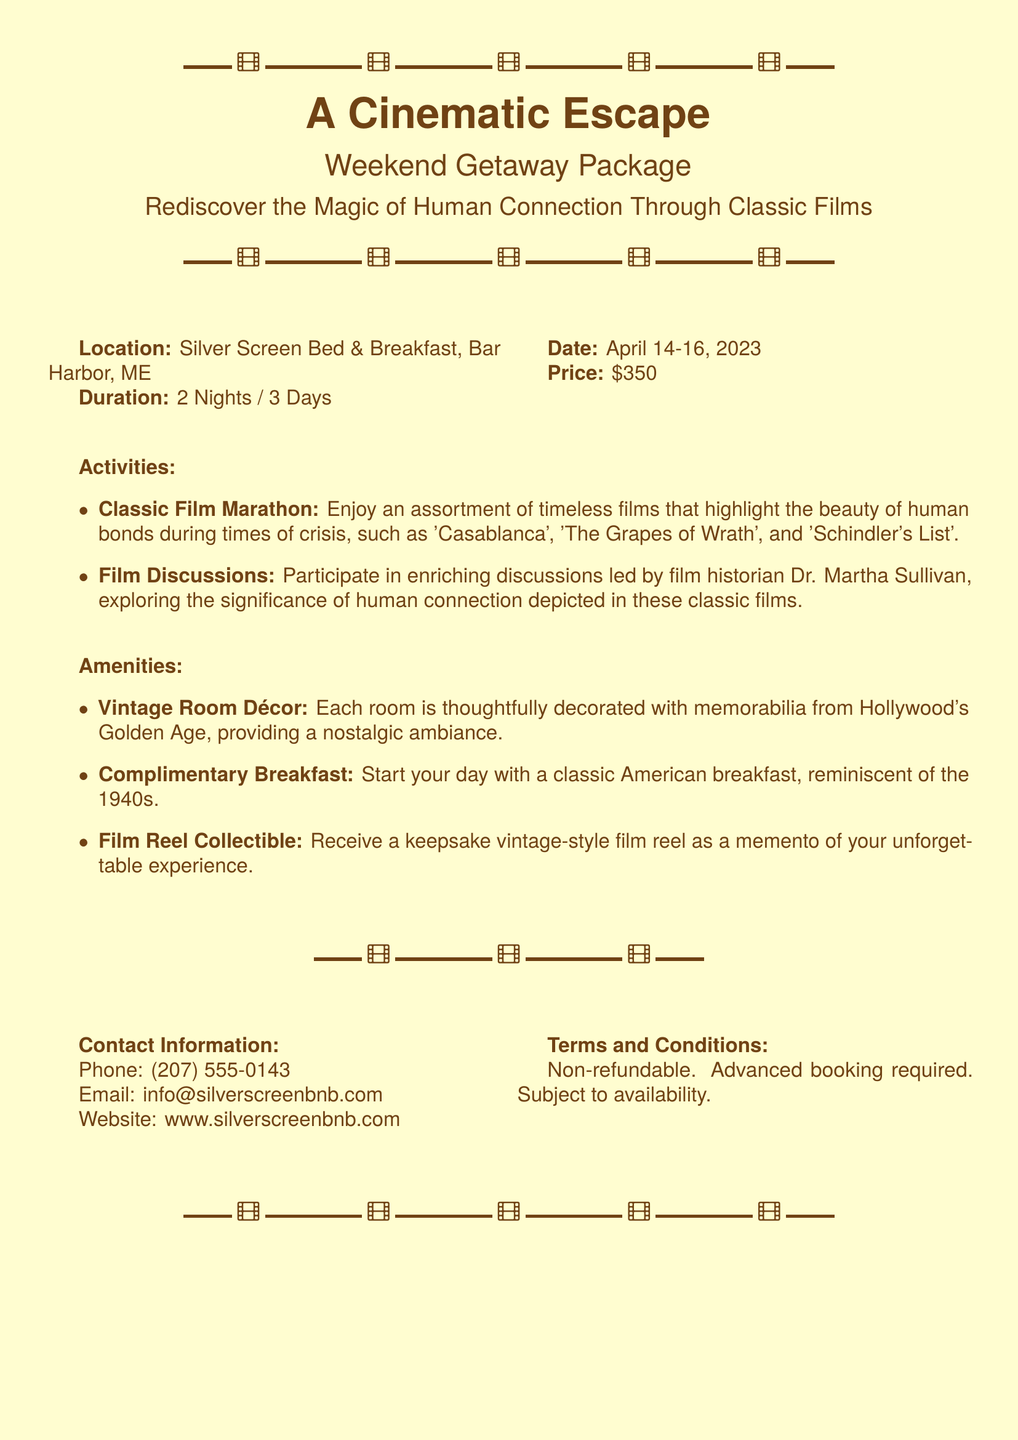What is the location of the getaway? The location is specified in the document as the Silver Screen Bed & Breakfast in Bar Harbor, ME.
Answer: Silver Screen Bed & Breakfast, Bar Harbor, ME What is the price of the weekend package? The price is clearly stated in the document under the price section.
Answer: $350 When is the getaway happening? The document provides the specific dates for the weekend getaway.
Answer: April 14-16, 2023 Who leads the film discussions? The document mentions Dr. Martha Sullivan as the film historian leading the discussions.
Answer: Dr. Martha Sullivan What type of breakfast is included? The document describes the breakfast provided as a classic American breakfast reminiscent of a certain decade.
Answer: Classic American breakfast What do guests receive as a memento? The document explains that guests will receive a specific collectible related to films.
Answer: Vintage-style film reel How many nights does the getaway last? The duration of the getaway is mentioned in the document as a specific number of nights.
Answer: 2 Nights What activity focuses on classic films? The document highlights a particular event that showcases classic films during the weekend.
Answer: Classic Film Marathon What is the booking status for the package? The document specifies the type of booking required for the package.
Answer: Advanced booking required 